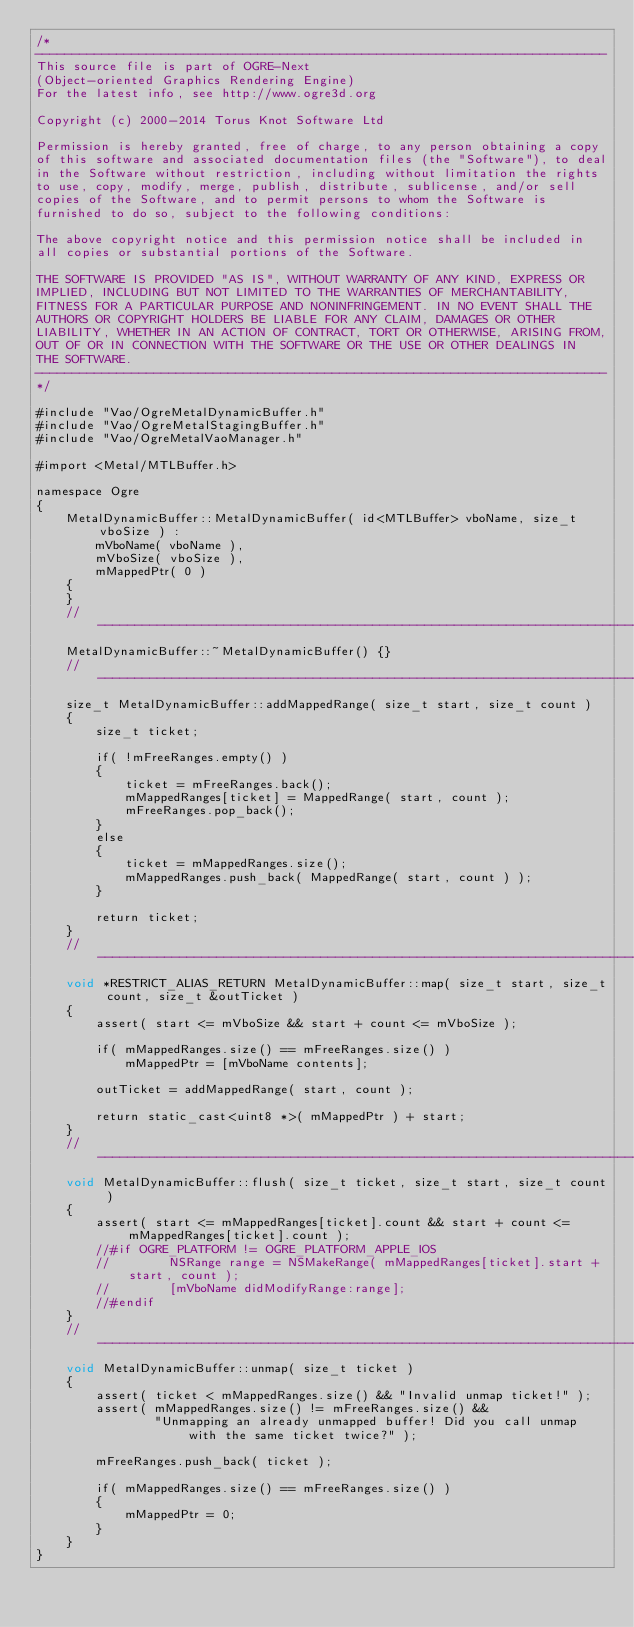<code> <loc_0><loc_0><loc_500><loc_500><_ObjectiveC_>/*
-----------------------------------------------------------------------------
This source file is part of OGRE-Next
(Object-oriented Graphics Rendering Engine)
For the latest info, see http://www.ogre3d.org

Copyright (c) 2000-2014 Torus Knot Software Ltd

Permission is hereby granted, free of charge, to any person obtaining a copy
of this software and associated documentation files (the "Software"), to deal
in the Software without restriction, including without limitation the rights
to use, copy, modify, merge, publish, distribute, sublicense, and/or sell
copies of the Software, and to permit persons to whom the Software is
furnished to do so, subject to the following conditions:

The above copyright notice and this permission notice shall be included in
all copies or substantial portions of the Software.

THE SOFTWARE IS PROVIDED "AS IS", WITHOUT WARRANTY OF ANY KIND, EXPRESS OR
IMPLIED, INCLUDING BUT NOT LIMITED TO THE WARRANTIES OF MERCHANTABILITY,
FITNESS FOR A PARTICULAR PURPOSE AND NONINFRINGEMENT. IN NO EVENT SHALL THE
AUTHORS OR COPYRIGHT HOLDERS BE LIABLE FOR ANY CLAIM, DAMAGES OR OTHER
LIABILITY, WHETHER IN AN ACTION OF CONTRACT, TORT OR OTHERWISE, ARISING FROM,
OUT OF OR IN CONNECTION WITH THE SOFTWARE OR THE USE OR OTHER DEALINGS IN
THE SOFTWARE.
-----------------------------------------------------------------------------
*/

#include "Vao/OgreMetalDynamicBuffer.h"
#include "Vao/OgreMetalStagingBuffer.h"
#include "Vao/OgreMetalVaoManager.h"

#import <Metal/MTLBuffer.h>

namespace Ogre
{
    MetalDynamicBuffer::MetalDynamicBuffer( id<MTLBuffer> vboName, size_t vboSize ) :
        mVboName( vboName ),
        mVboSize( vboSize ),
        mMappedPtr( 0 )
    {
    }
    //-----------------------------------------------------------------------------------
    MetalDynamicBuffer::~MetalDynamicBuffer() {}
    //-----------------------------------------------------------------------------------
    size_t MetalDynamicBuffer::addMappedRange( size_t start, size_t count )
    {
        size_t ticket;

        if( !mFreeRanges.empty() )
        {
            ticket = mFreeRanges.back();
            mMappedRanges[ticket] = MappedRange( start, count );
            mFreeRanges.pop_back();
        }
        else
        {
            ticket = mMappedRanges.size();
            mMappedRanges.push_back( MappedRange( start, count ) );
        }

        return ticket;
    }
    //-----------------------------------------------------------------------------------
    void *RESTRICT_ALIAS_RETURN MetalDynamicBuffer::map( size_t start, size_t count, size_t &outTicket )
    {
        assert( start <= mVboSize && start + count <= mVboSize );

        if( mMappedRanges.size() == mFreeRanges.size() )
            mMappedPtr = [mVboName contents];

        outTicket = addMappedRange( start, count );

        return static_cast<uint8 *>( mMappedPtr ) + start;
    }
    //-----------------------------------------------------------------------------------
    void MetalDynamicBuffer::flush( size_t ticket, size_t start, size_t count )
    {
        assert( start <= mMappedRanges[ticket].count && start + count <= mMappedRanges[ticket].count );
        //#if OGRE_PLATFORM != OGRE_PLATFORM_APPLE_IOS
        //        NSRange range = NSMakeRange( mMappedRanges[ticket].start + start, count );
        //        [mVboName didModifyRange:range];
        //#endif
    }
    //-----------------------------------------------------------------------------------
    void MetalDynamicBuffer::unmap( size_t ticket )
    {
        assert( ticket < mMappedRanges.size() && "Invalid unmap ticket!" );
        assert( mMappedRanges.size() != mFreeRanges.size() &&
                "Unmapping an already unmapped buffer! Did you call unmap with the same ticket twice?" );

        mFreeRanges.push_back( ticket );

        if( mMappedRanges.size() == mFreeRanges.size() )
        {
            mMappedPtr = 0;
        }
    }
}
</code> 